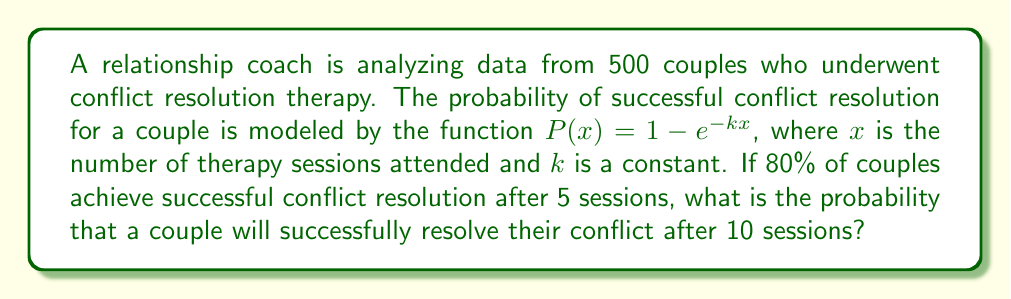Solve this math problem. Let's approach this step-by-step:

1) We're given that $P(x) = 1 - e^{-kx}$, where $P(x)$ is the probability of success after $x$ sessions.

2) We're told that after 5 sessions, 80% of couples achieve success. This means:

   $P(5) = 0.8 = 1 - e^{-5k}$

3) Let's solve this equation for $k$:
   
   $e^{-5k} = 1 - 0.8 = 0.2$
   
   $-5k = \ln(0.2)$
   
   $k = -\frac{\ln(0.2)}{5} \approx 0.3219$

4) Now that we know $k$, we can calculate the probability of success after 10 sessions:

   $P(10) = 1 - e^{-k(10)}$
   
   $= 1 - e^{-0.3219(10)}$
   
   $= 1 - e^{-3.219}$
   
   $= 1 - 0.0400$
   
   $= 0.9600$

5) Therefore, the probability of successful conflict resolution after 10 sessions is approximately 0.9600 or 96.00%.
Answer: 0.9600 (or 96.00%) 